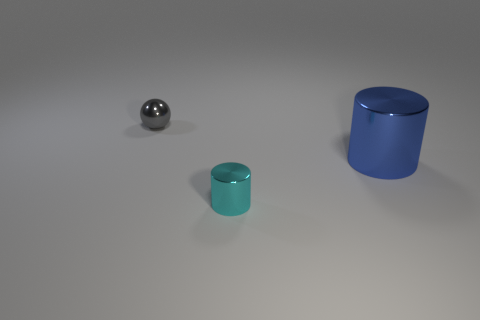There is a object in front of the large metal object; is there a metal cylinder that is on the right side of it?
Offer a very short reply. Yes. Is the shape of the small gray thing the same as the thing that is to the right of the small cyan shiny object?
Your answer should be very brief. No. There is a thing on the left side of the cyan cylinder; what color is it?
Offer a very short reply. Gray. There is a cylinder behind the small metallic thing that is on the right side of the small gray metal ball; what is its size?
Your response must be concise. Large. There is a shiny object that is behind the large object; does it have the same shape as the blue shiny thing?
Your answer should be compact. No. There is a big object that is the same shape as the tiny cyan metallic object; what material is it?
Your answer should be compact. Metal. How many things are either tiny metallic objects in front of the gray object or blue cylinders that are to the right of the cyan metal cylinder?
Keep it short and to the point. 2. Do the metallic sphere and the tiny metallic object that is in front of the gray ball have the same color?
Ensure brevity in your answer.  No. The gray object that is made of the same material as the blue thing is what shape?
Provide a succinct answer. Sphere. How many shiny things are there?
Your response must be concise. 3. 